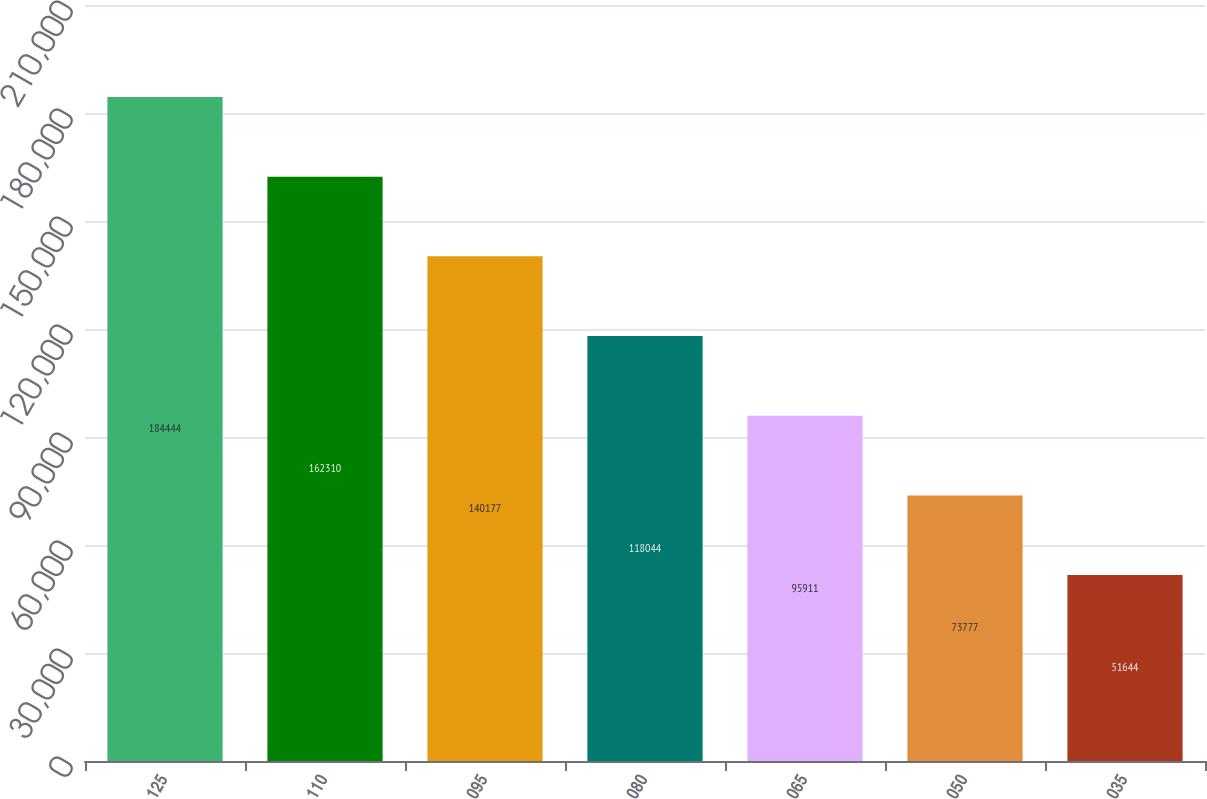Convert chart to OTSL. <chart><loc_0><loc_0><loc_500><loc_500><bar_chart><fcel>125<fcel>110<fcel>095<fcel>080<fcel>065<fcel>050<fcel>035<nl><fcel>184444<fcel>162310<fcel>140177<fcel>118044<fcel>95911<fcel>73777<fcel>51644<nl></chart> 